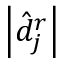<formula> <loc_0><loc_0><loc_500><loc_500>\left | \hat { d } _ { j } ^ { r } \right |</formula> 